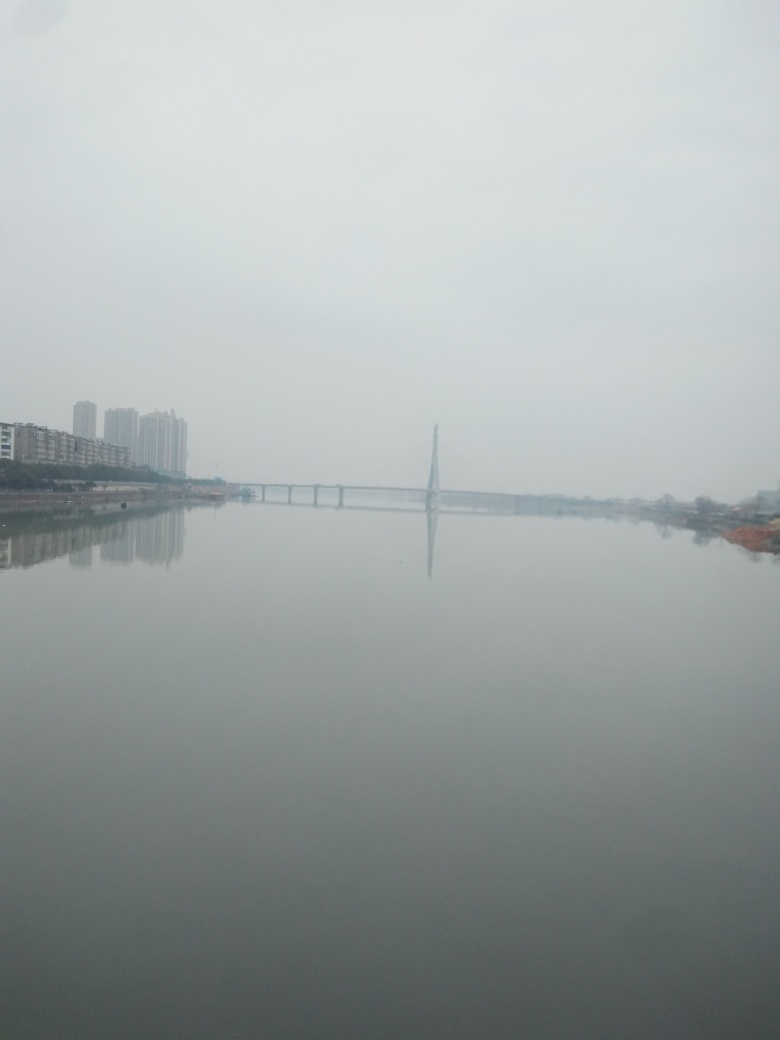In terms of photography, how could this image be improved? From a photographic standpoint, the image could benefit from adjusting the exposure and contrast to enhance detail and reduce the overcast effect. The composition might be improved through the rule of thirds, by adjusting the camera angle to include more interesting foreground elements, or by reducing the empty sky space to create more balance. Using a higher resolution camera or editing the image post-capture to sharpen the details could also improve its overall quality. 